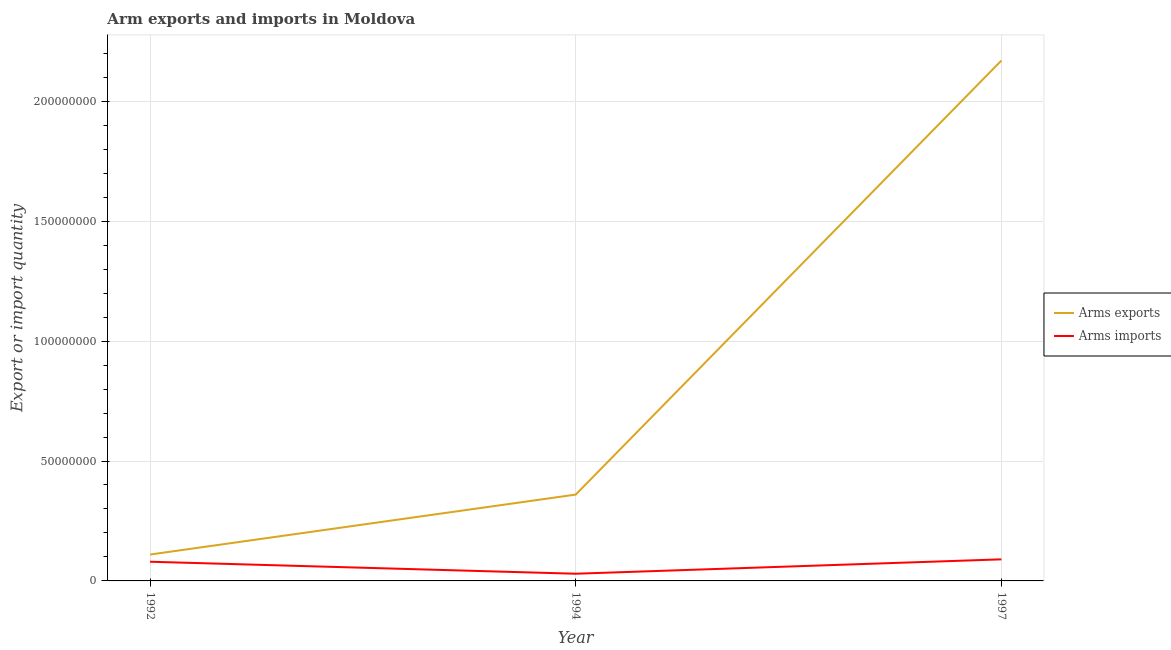How many different coloured lines are there?
Your response must be concise. 2. Is the number of lines equal to the number of legend labels?
Your answer should be very brief. Yes. What is the arms imports in 1994?
Make the answer very short. 3.00e+06. Across all years, what is the maximum arms imports?
Offer a very short reply. 9.00e+06. Across all years, what is the minimum arms imports?
Make the answer very short. 3.00e+06. In which year was the arms imports maximum?
Your response must be concise. 1997. What is the total arms exports in the graph?
Give a very brief answer. 2.64e+08. What is the difference between the arms exports in 1992 and that in 1997?
Offer a terse response. -2.06e+08. What is the difference between the arms exports in 1994 and the arms imports in 1997?
Your answer should be compact. 2.70e+07. What is the average arms exports per year?
Keep it short and to the point. 8.80e+07. In the year 1992, what is the difference between the arms exports and arms imports?
Your answer should be compact. 3.00e+06. What is the ratio of the arms exports in 1994 to that in 1997?
Your answer should be very brief. 0.17. What is the difference between the highest and the second highest arms exports?
Ensure brevity in your answer.  1.81e+08. What is the difference between the highest and the lowest arms imports?
Your answer should be very brief. 6.00e+06. Is the arms imports strictly greater than the arms exports over the years?
Keep it short and to the point. No. How many years are there in the graph?
Provide a short and direct response. 3. Are the values on the major ticks of Y-axis written in scientific E-notation?
Your answer should be compact. No. Does the graph contain any zero values?
Your answer should be very brief. No. Where does the legend appear in the graph?
Your answer should be compact. Center right. How many legend labels are there?
Your answer should be compact. 2. What is the title of the graph?
Make the answer very short. Arm exports and imports in Moldova. What is the label or title of the X-axis?
Keep it short and to the point. Year. What is the label or title of the Y-axis?
Give a very brief answer. Export or import quantity. What is the Export or import quantity of Arms exports in 1992?
Your answer should be very brief. 1.10e+07. What is the Export or import quantity in Arms exports in 1994?
Your answer should be compact. 3.60e+07. What is the Export or import quantity in Arms imports in 1994?
Provide a short and direct response. 3.00e+06. What is the Export or import quantity in Arms exports in 1997?
Your answer should be very brief. 2.17e+08. What is the Export or import quantity of Arms imports in 1997?
Offer a terse response. 9.00e+06. Across all years, what is the maximum Export or import quantity in Arms exports?
Your response must be concise. 2.17e+08. Across all years, what is the maximum Export or import quantity of Arms imports?
Ensure brevity in your answer.  9.00e+06. Across all years, what is the minimum Export or import quantity in Arms exports?
Your answer should be very brief. 1.10e+07. Across all years, what is the minimum Export or import quantity of Arms imports?
Your response must be concise. 3.00e+06. What is the total Export or import quantity of Arms exports in the graph?
Provide a succinct answer. 2.64e+08. What is the total Export or import quantity in Arms imports in the graph?
Your answer should be very brief. 2.00e+07. What is the difference between the Export or import quantity in Arms exports in 1992 and that in 1994?
Your answer should be compact. -2.50e+07. What is the difference between the Export or import quantity in Arms exports in 1992 and that in 1997?
Provide a succinct answer. -2.06e+08. What is the difference between the Export or import quantity in Arms imports in 1992 and that in 1997?
Offer a very short reply. -1.00e+06. What is the difference between the Export or import quantity of Arms exports in 1994 and that in 1997?
Provide a succinct answer. -1.81e+08. What is the difference between the Export or import quantity in Arms imports in 1994 and that in 1997?
Keep it short and to the point. -6.00e+06. What is the difference between the Export or import quantity of Arms exports in 1994 and the Export or import quantity of Arms imports in 1997?
Give a very brief answer. 2.70e+07. What is the average Export or import quantity of Arms exports per year?
Keep it short and to the point. 8.80e+07. What is the average Export or import quantity of Arms imports per year?
Offer a terse response. 6.67e+06. In the year 1994, what is the difference between the Export or import quantity in Arms exports and Export or import quantity in Arms imports?
Offer a terse response. 3.30e+07. In the year 1997, what is the difference between the Export or import quantity of Arms exports and Export or import quantity of Arms imports?
Offer a very short reply. 2.08e+08. What is the ratio of the Export or import quantity in Arms exports in 1992 to that in 1994?
Keep it short and to the point. 0.31. What is the ratio of the Export or import quantity in Arms imports in 1992 to that in 1994?
Your answer should be very brief. 2.67. What is the ratio of the Export or import quantity in Arms exports in 1992 to that in 1997?
Keep it short and to the point. 0.05. What is the ratio of the Export or import quantity of Arms imports in 1992 to that in 1997?
Make the answer very short. 0.89. What is the ratio of the Export or import quantity in Arms exports in 1994 to that in 1997?
Your response must be concise. 0.17. What is the ratio of the Export or import quantity in Arms imports in 1994 to that in 1997?
Offer a very short reply. 0.33. What is the difference between the highest and the second highest Export or import quantity of Arms exports?
Your answer should be compact. 1.81e+08. What is the difference between the highest and the second highest Export or import quantity in Arms imports?
Ensure brevity in your answer.  1.00e+06. What is the difference between the highest and the lowest Export or import quantity of Arms exports?
Provide a short and direct response. 2.06e+08. What is the difference between the highest and the lowest Export or import quantity in Arms imports?
Your response must be concise. 6.00e+06. 